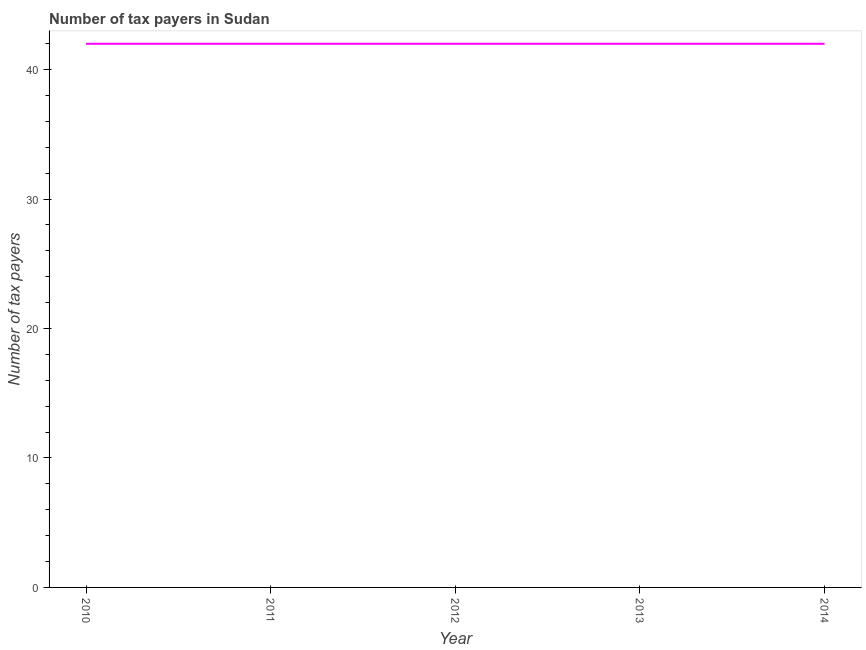What is the number of tax payers in 2013?
Your response must be concise. 42. Across all years, what is the maximum number of tax payers?
Your answer should be very brief. 42. Across all years, what is the minimum number of tax payers?
Provide a succinct answer. 42. In which year was the number of tax payers maximum?
Ensure brevity in your answer.  2010. What is the sum of the number of tax payers?
Your response must be concise. 210. What is the average number of tax payers per year?
Provide a succinct answer. 42. What is the median number of tax payers?
Ensure brevity in your answer.  42. Do a majority of the years between 2010 and 2014 (inclusive) have number of tax payers greater than 6 ?
Offer a very short reply. Yes. Is the number of tax payers in 2010 less than that in 2011?
Provide a short and direct response. No. Is the difference between the number of tax payers in 2010 and 2013 greater than the difference between any two years?
Give a very brief answer. Yes. What is the difference between the highest and the lowest number of tax payers?
Keep it short and to the point. 0. In how many years, is the number of tax payers greater than the average number of tax payers taken over all years?
Your answer should be compact. 0. Does the number of tax payers monotonically increase over the years?
Your answer should be very brief. No. Are the values on the major ticks of Y-axis written in scientific E-notation?
Offer a very short reply. No. Does the graph contain any zero values?
Your answer should be compact. No. What is the title of the graph?
Provide a short and direct response. Number of tax payers in Sudan. What is the label or title of the Y-axis?
Provide a succinct answer. Number of tax payers. What is the Number of tax payers in 2010?
Keep it short and to the point. 42. What is the Number of tax payers of 2013?
Offer a terse response. 42. What is the difference between the Number of tax payers in 2010 and 2012?
Ensure brevity in your answer.  0. What is the difference between the Number of tax payers in 2010 and 2013?
Provide a succinct answer. 0. What is the difference between the Number of tax payers in 2010 and 2014?
Provide a succinct answer. 0. What is the difference between the Number of tax payers in 2011 and 2012?
Ensure brevity in your answer.  0. What is the difference between the Number of tax payers in 2011 and 2013?
Offer a very short reply. 0. What is the difference between the Number of tax payers in 2012 and 2014?
Offer a very short reply. 0. What is the ratio of the Number of tax payers in 2010 to that in 2011?
Provide a succinct answer. 1. What is the ratio of the Number of tax payers in 2010 to that in 2012?
Your response must be concise. 1. What is the ratio of the Number of tax payers in 2010 to that in 2013?
Make the answer very short. 1. What is the ratio of the Number of tax payers in 2010 to that in 2014?
Provide a succinct answer. 1. What is the ratio of the Number of tax payers in 2012 to that in 2013?
Give a very brief answer. 1. What is the ratio of the Number of tax payers in 2012 to that in 2014?
Ensure brevity in your answer.  1. What is the ratio of the Number of tax payers in 2013 to that in 2014?
Your answer should be very brief. 1. 